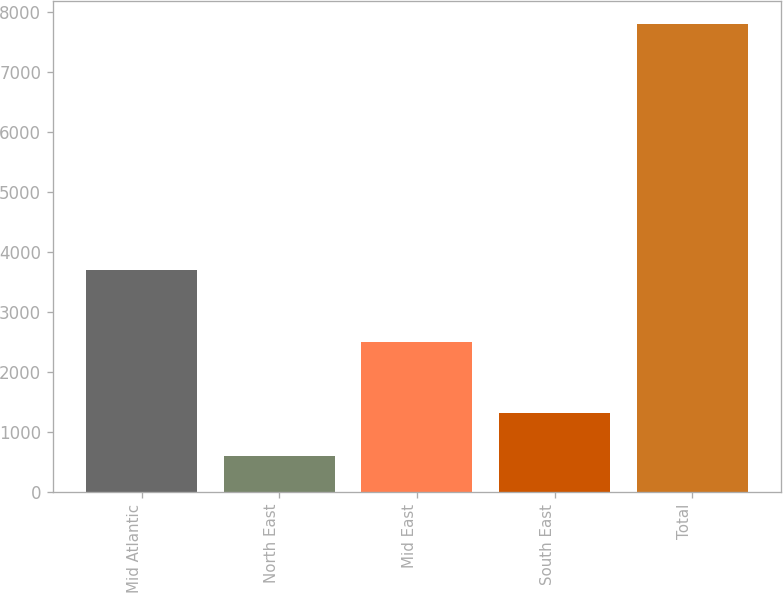<chart> <loc_0><loc_0><loc_500><loc_500><bar_chart><fcel>Mid Atlantic<fcel>North East<fcel>Mid East<fcel>South East<fcel>Total<nl><fcel>3700<fcel>600<fcel>2500<fcel>1320<fcel>7800<nl></chart> 